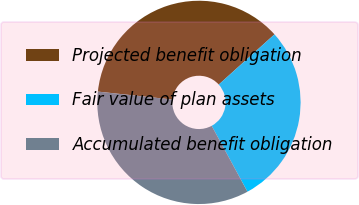Convert chart. <chart><loc_0><loc_0><loc_500><loc_500><pie_chart><fcel>Projected benefit obligation<fcel>Fair value of plan assets<fcel>Accumulated benefit obligation<nl><fcel>36.64%<fcel>28.75%<fcel>34.62%<nl></chart> 